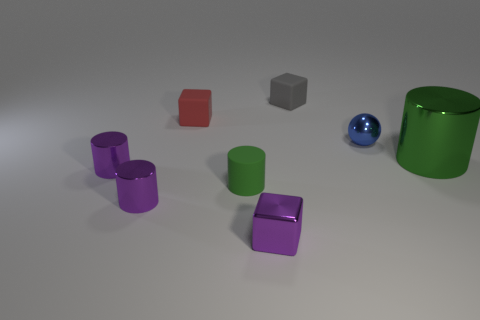Is the small sphere the same color as the large shiny thing?
Your answer should be very brief. No. There is another cylinder that is the same color as the tiny matte cylinder; what is its material?
Give a very brief answer. Metal. Are there fewer tiny red rubber cubes in front of the tiny purple metallic block than green metallic cylinders that are in front of the large cylinder?
Make the answer very short. No. Is the material of the blue sphere the same as the large green cylinder?
Ensure brevity in your answer.  Yes. What is the size of the block that is left of the tiny gray matte thing and behind the blue shiny thing?
Offer a very short reply. Small. Are there an equal number of big green shiny objects and big cyan matte cylinders?
Your answer should be compact. No. The red thing that is the same size as the metal sphere is what shape?
Provide a short and direct response. Cube. The block in front of the matte cube that is to the left of the cube in front of the small metal sphere is made of what material?
Your response must be concise. Metal. There is a matte object that is in front of the ball; does it have the same shape as the green thing that is behind the green matte cylinder?
Give a very brief answer. Yes. What number of other things are the same material as the tiny red cube?
Give a very brief answer. 2. 